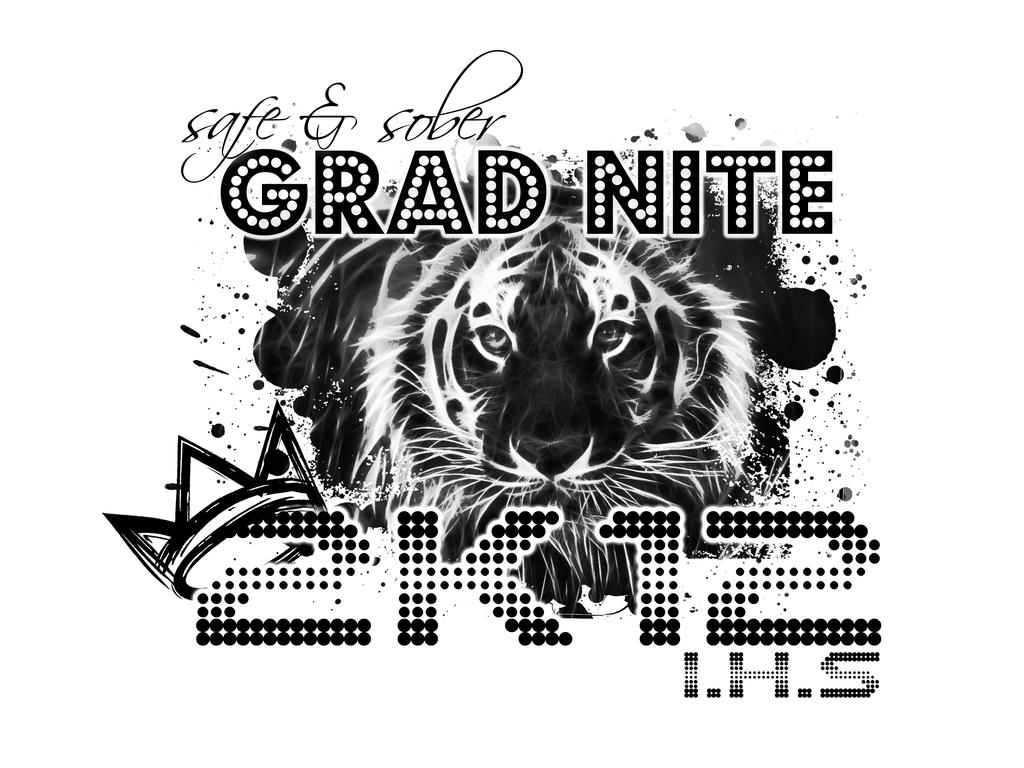What type of image is being described? The image is an animated picture. What type of pollution is visible in the animated picture? There is no information provided about pollution in the image, and the image is not described as containing any pollution. 